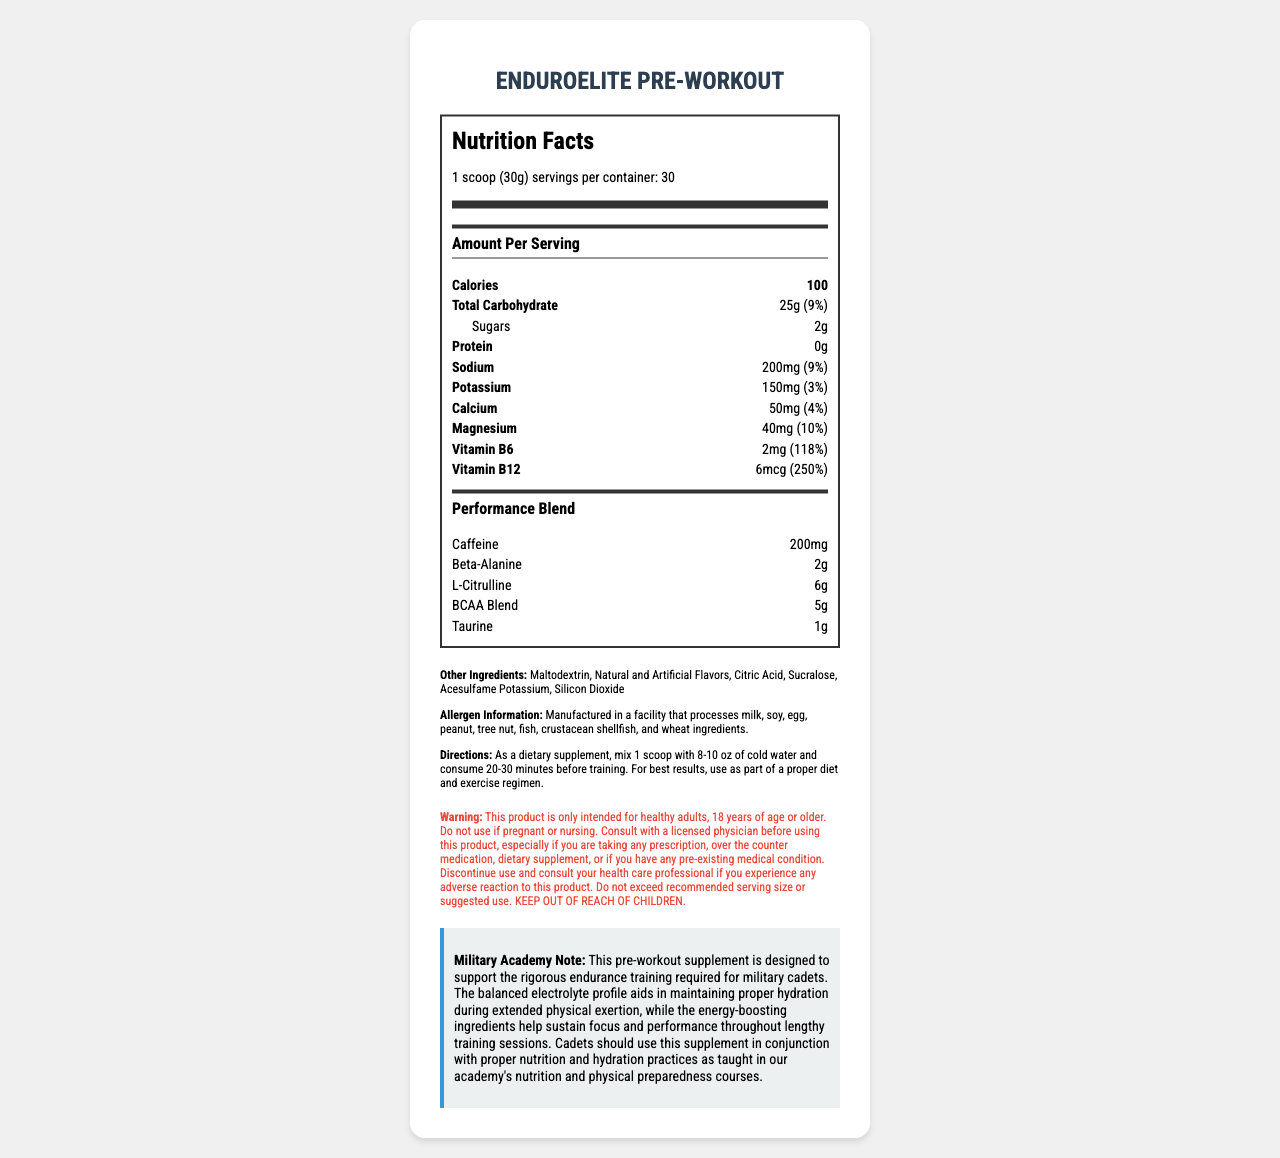What is the serving size of EnduroElite Pre-Workout? The serving size is clearly listed at the very top of the Nutrition Facts Label as "1 scoop (30g)".
Answer: 1 scoop (30g) How many calories are there per serving? The amount of calories per serving is listed as "100" in the Amount Per Serving section.
Answer: 100 How much sodium does one serving contain? The sodium content per serving is specified as "200mg", with a daily value of "9%".
Answer: 200mg (9%) Which electrolyte has the highest daily value percentage in this supplement? A. Sodium B. Potassium C. Calcium D. Magnesium Magnesium has a daily value of "10%", which is the highest among the listed electrolytes.
Answer: D Does this product contain any protein? The protein amount is listed as "0g" in the nutrient row.
Answer: No What are the key ingredients in the BCAA Blend? The document lists the ingredients of the BCAA Blend as "L-Leucine, L-Isoleucine, L-Valine".
Answer: L-Leucine, L-Isoleucine, L-Valine Is this product suitable for someone who is pregnant or nursing? The warning section explicitly states that the product is not intended for pregnant or nursing individuals.
Answer: No How should this pre-workout supplement be consumed for best results? A. 10-15 minutes before training B. 20-30 minutes before training C. 30-40 minutes before training The directions section advises consuming the supplement "20-30 minutes before training" for best results.
Answer: B What is the primary purpose of this supplement according to the military academy note? The note explains that the supplement supports rigorous endurance training and helps maintain hydration during extended physical activities.
Answer: To support rigorous endurance training and maintain hydration How many servings are there per container of EnduroElite Pre-Workout? The serving information at the top of the nutrition label states there are "30 servings per container".
Answer: 30 servings What is the caffeine content per serving? The caffeine content is listed as "200mg" under the Performance Blend section.
Answer: 200mg Is there any detailed information available on the long-term effects of consuming this supplement? The document does not provide any information regarding the long-term effects of consuming the supplement.
Answer: Not enough information Summarize the main purpose of the EnduroElite Pre-Workout supplement. The summary captures the key features and intended use of the supplement, as detailed throughout the document including the nutrition facts, performance ingredients, and military academy note.
Answer: The EnduroElite Pre-Workout supplement is designed to enhance performance and endurance during training sessions for military cadets. It balances electrolytes to maintain hydration and contains energy-boosting ingredients like caffeine, beta-alanine, L-citrulline, and BCAA Blend to support focus and performance. Directions for use and various warnings are provided to ensure safe consumption. 